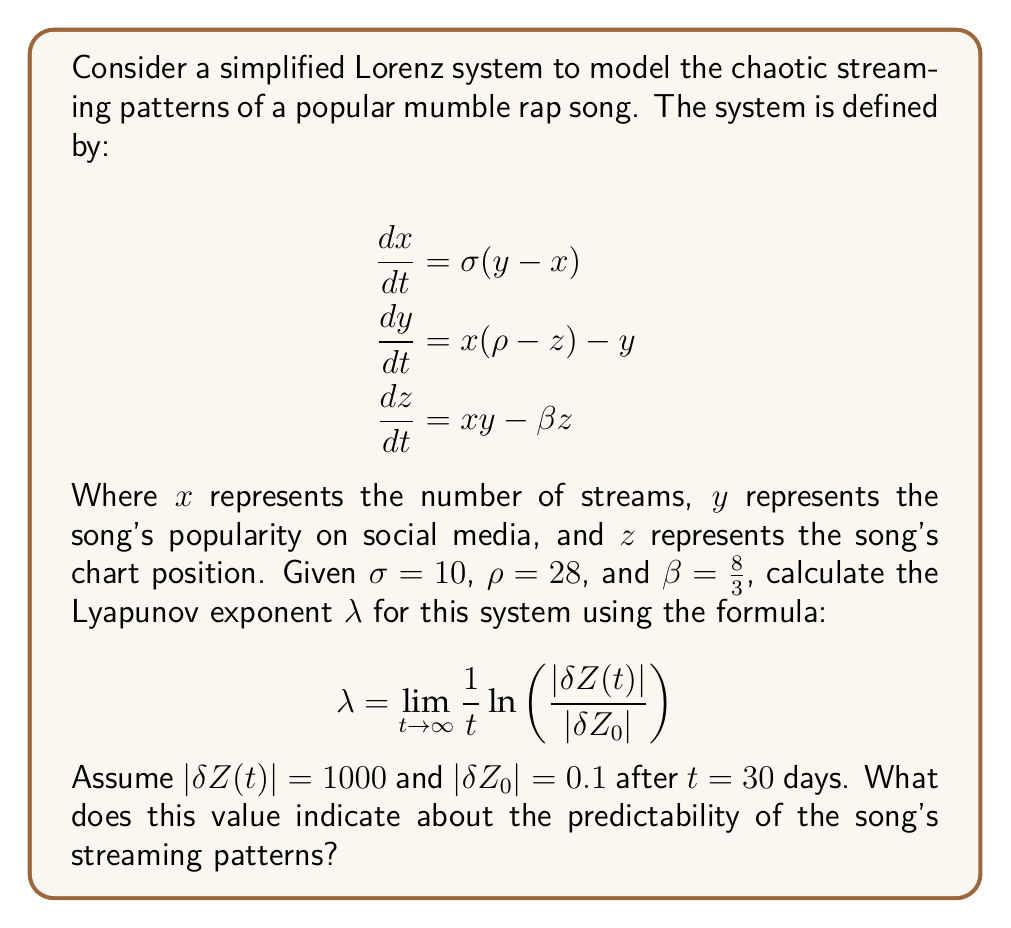Solve this math problem. To solve this problem, we'll follow these steps:

1) We're given the formula for the Lyapunov exponent:

   $$\lambda = \lim_{t \to \infty} \frac{1}{t} \ln \left(\frac{|\delta Z(t)|}{|\delta Z_0|}\right)$$

2) We're also given the values:
   $|\delta Z(t)| = 1000$
   $|\delta Z_0| = 0.1$
   $t = 30$ days

3) Let's substitute these values into the formula:

   $$\lambda = \frac{1}{30} \ln \left(\frac{1000}{0.1}\right)$$

4) Simplify inside the logarithm:

   $$\lambda = \frac{1}{30} \ln (10000)$$

5) Use the logarithm property $\ln(10000) = \ln(10^4) = 4\ln(10)$:

   $$\lambda = \frac{1}{30} (4\ln(10))$$

6) Calculate:
   $4\ln(10) \approx 9.2103$
   
   $$\lambda = \frac{9.2103}{30} \approx 0.3070$$

7) Interpret the result: A positive Lyapunov exponent ($\lambda > 0$) indicates chaotic behavior. The magnitude (0.3070) suggests a moderate level of chaos, meaning the streaming patterns of the mumble rap song are unpredictable in the long term. Small changes in initial conditions can lead to significantly different outcomes over time.
Answer: $\lambda \approx 0.3070$, indicating chaotic and unpredictable streaming patterns. 